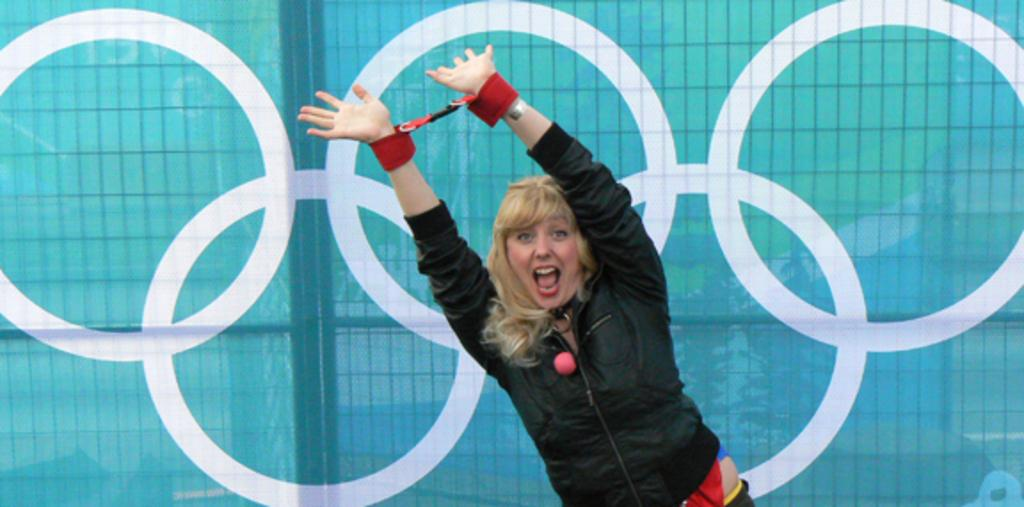Who is the main subject in the image? There is a lady in the center of the image. What is the lady doing in the image? The lady is raising her hands. What can be seen in the background of the image? There is a banner in the background of the image. Can you see any lake in the image? There is no lake present in the image. What type of paste is being used by the lady in the image? There is no paste visible in the image, and the lady is not using any paste. 